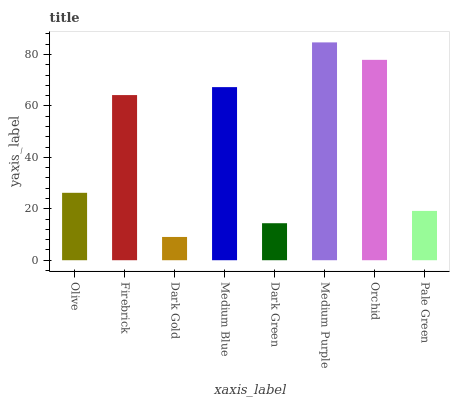Is Dark Gold the minimum?
Answer yes or no. Yes. Is Medium Purple the maximum?
Answer yes or no. Yes. Is Firebrick the minimum?
Answer yes or no. No. Is Firebrick the maximum?
Answer yes or no. No. Is Firebrick greater than Olive?
Answer yes or no. Yes. Is Olive less than Firebrick?
Answer yes or no. Yes. Is Olive greater than Firebrick?
Answer yes or no. No. Is Firebrick less than Olive?
Answer yes or no. No. Is Firebrick the high median?
Answer yes or no. Yes. Is Olive the low median?
Answer yes or no. Yes. Is Dark Gold the high median?
Answer yes or no. No. Is Medium Purple the low median?
Answer yes or no. No. 